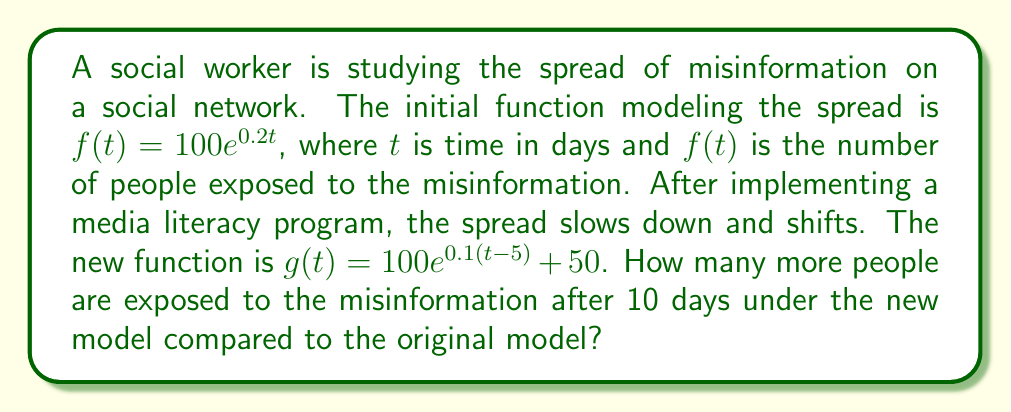Could you help me with this problem? Let's approach this step-by-step:

1) First, we need to calculate the number of people exposed after 10 days under the original model:

   $f(10) = 100e^{0.2(10)} = 100e^2 \approx 738.91$

2) Now, let's calculate the number of people exposed after 10 days under the new model:

   $g(10) = 100e^{0.1(10-5)} + 50$

3) Simplify the exponent:
   
   $g(10) = 100e^{0.1(5)} + 50 = 100e^{0.5} + 50$

4) Calculate:
   
   $g(10) = 100 \cdot 1.6487 + 50 \approx 214.87$

5) To find how many more people are exposed under the new model, we subtract:

   $214.87 - 738.91 = -524.04$

6) The negative result indicates that fewer people are exposed under the new model.

7) To find how many more people are exposed under the original model, we take the absolute value:

   $|214.87 - 738.91| = 524.04$

Therefore, approximately 524 more people are exposed to the misinformation after 10 days under the original model compared to the new model.
Answer: 524 people 